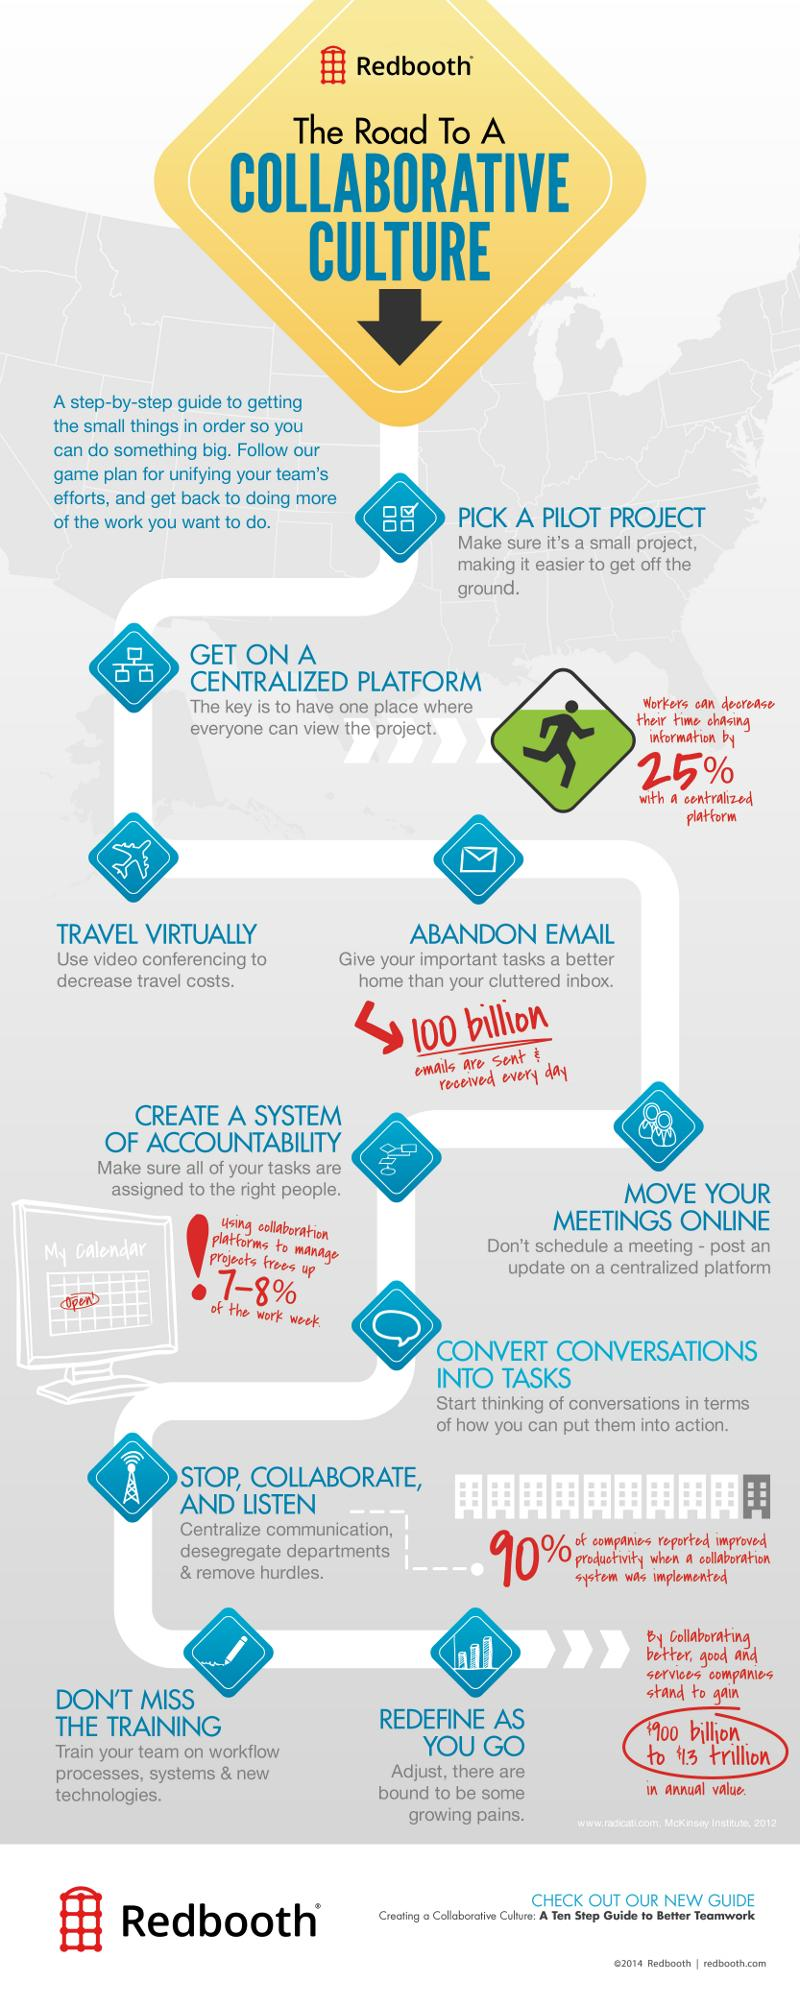Draw attention to some important aspects in this diagram. It is essential to initiate a collaborative culture by selecting a pilot project as the first step. After selecting a pilot project, the next step is to move forward with implementing it on a centralized platform. 